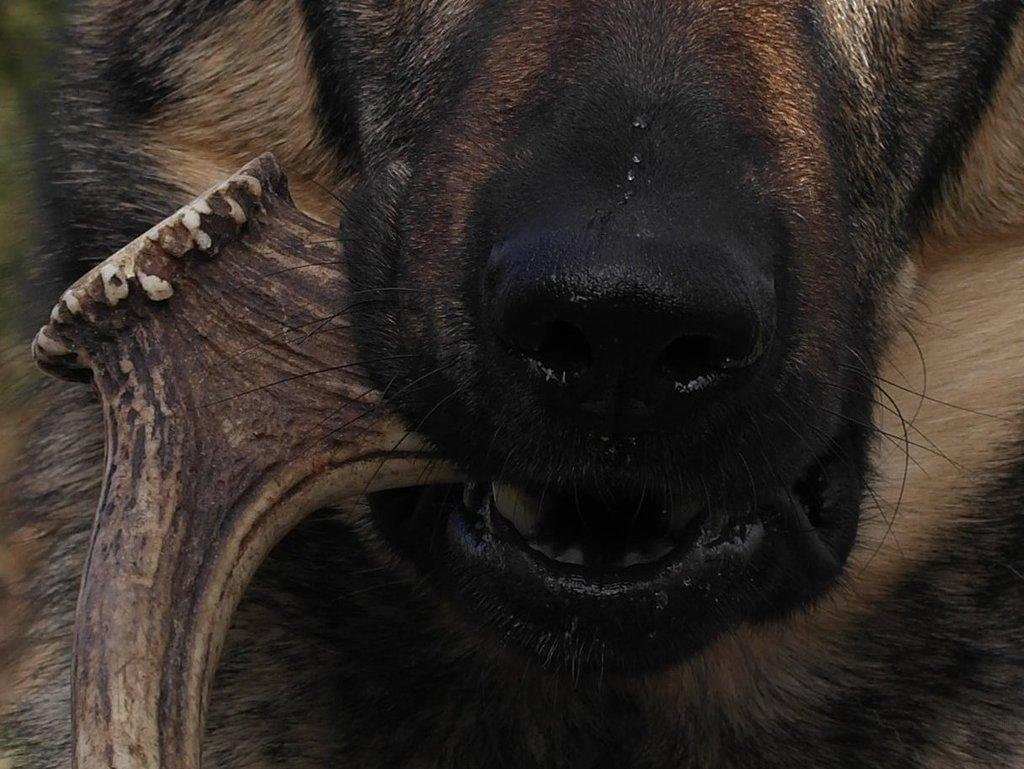What type of creature is present in the image? There is an animal in the image. What is the animal doing in the image? The animal is holding an object with its mouth. What type of house is visible in the image? There is no house present in the image; it only features an animal holding an object with its mouth. What type of stamp can be seen on the animal's apparel in the image? There is no stamp or apparel present in the image; it only features an animal holding an object with its mouth. 